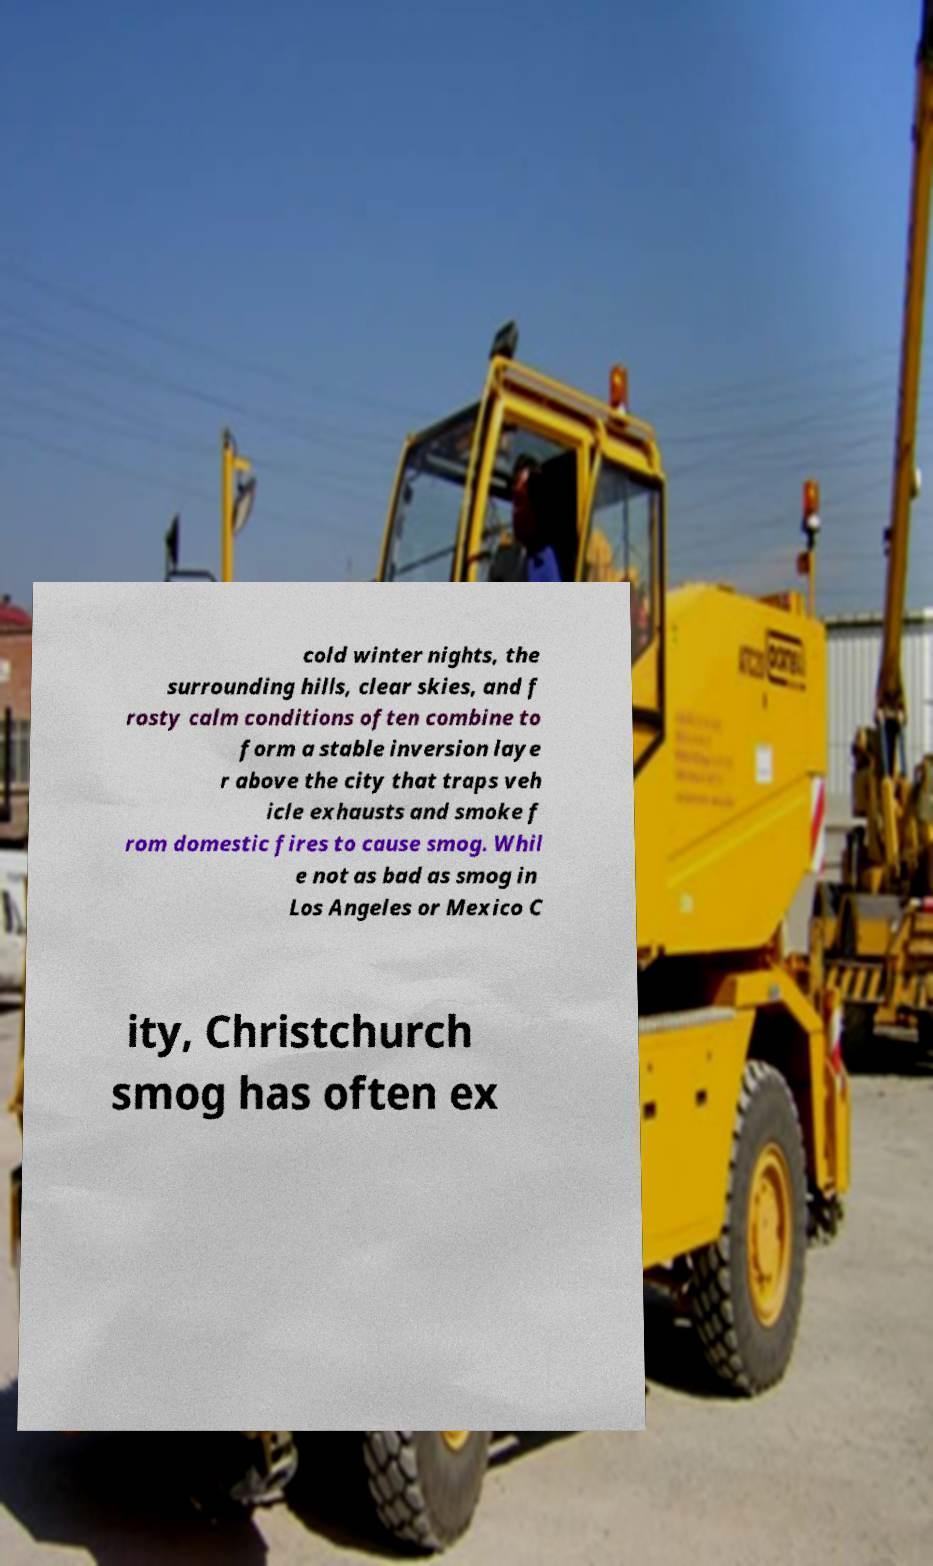Could you assist in decoding the text presented in this image and type it out clearly? cold winter nights, the surrounding hills, clear skies, and f rosty calm conditions often combine to form a stable inversion laye r above the city that traps veh icle exhausts and smoke f rom domestic fires to cause smog. Whil e not as bad as smog in Los Angeles or Mexico C ity, Christchurch smog has often ex 